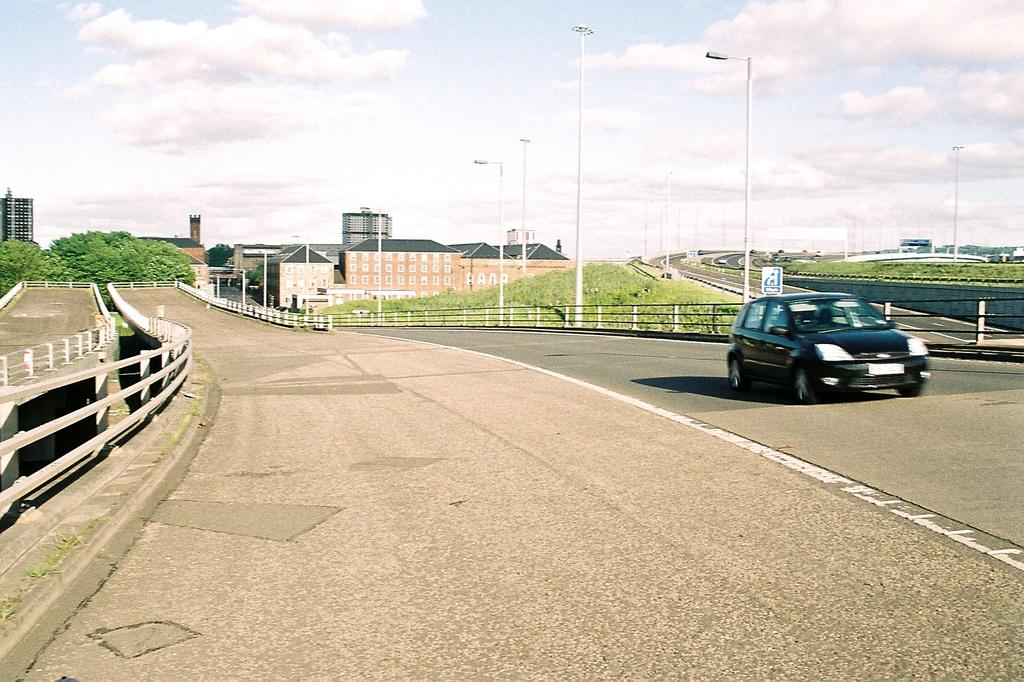What is the main subject of the image? The main subject of the image is a car on the road. What structures can be seen in the image? There are light poles, a building, and trees in the image. What type of vegetation is present in the image? There is grass in the image. What part of the building is visible in the image? The windows of the building are visible in the image. What might be used to separate or protect areas in the image? There is a barrier in the image. What organization is responsible for the car's performance in the image? There is no organization mentioned or implied in the image; it simply shows a car on the road. Can you tell me how the car is sailing in the image? The car is not sailing in the image; it is driving on the road. 